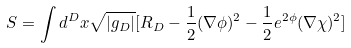<formula> <loc_0><loc_0><loc_500><loc_500>S = \int d ^ { D } x \sqrt { | g _ { D } | } [ R _ { D } - \frac { 1 } { 2 } ( \nabla \phi ) ^ { 2 } - \frac { 1 } { 2 } e ^ { 2 \phi } ( \nabla \chi ) ^ { 2 } ]</formula> 